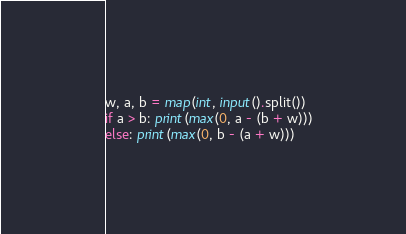<code> <loc_0><loc_0><loc_500><loc_500><_Python_>w, a, b = map(int, input().split())
if a > b: print(max(0, a - (b + w)))
else: print(max(0, b - (a + w)))
</code> 